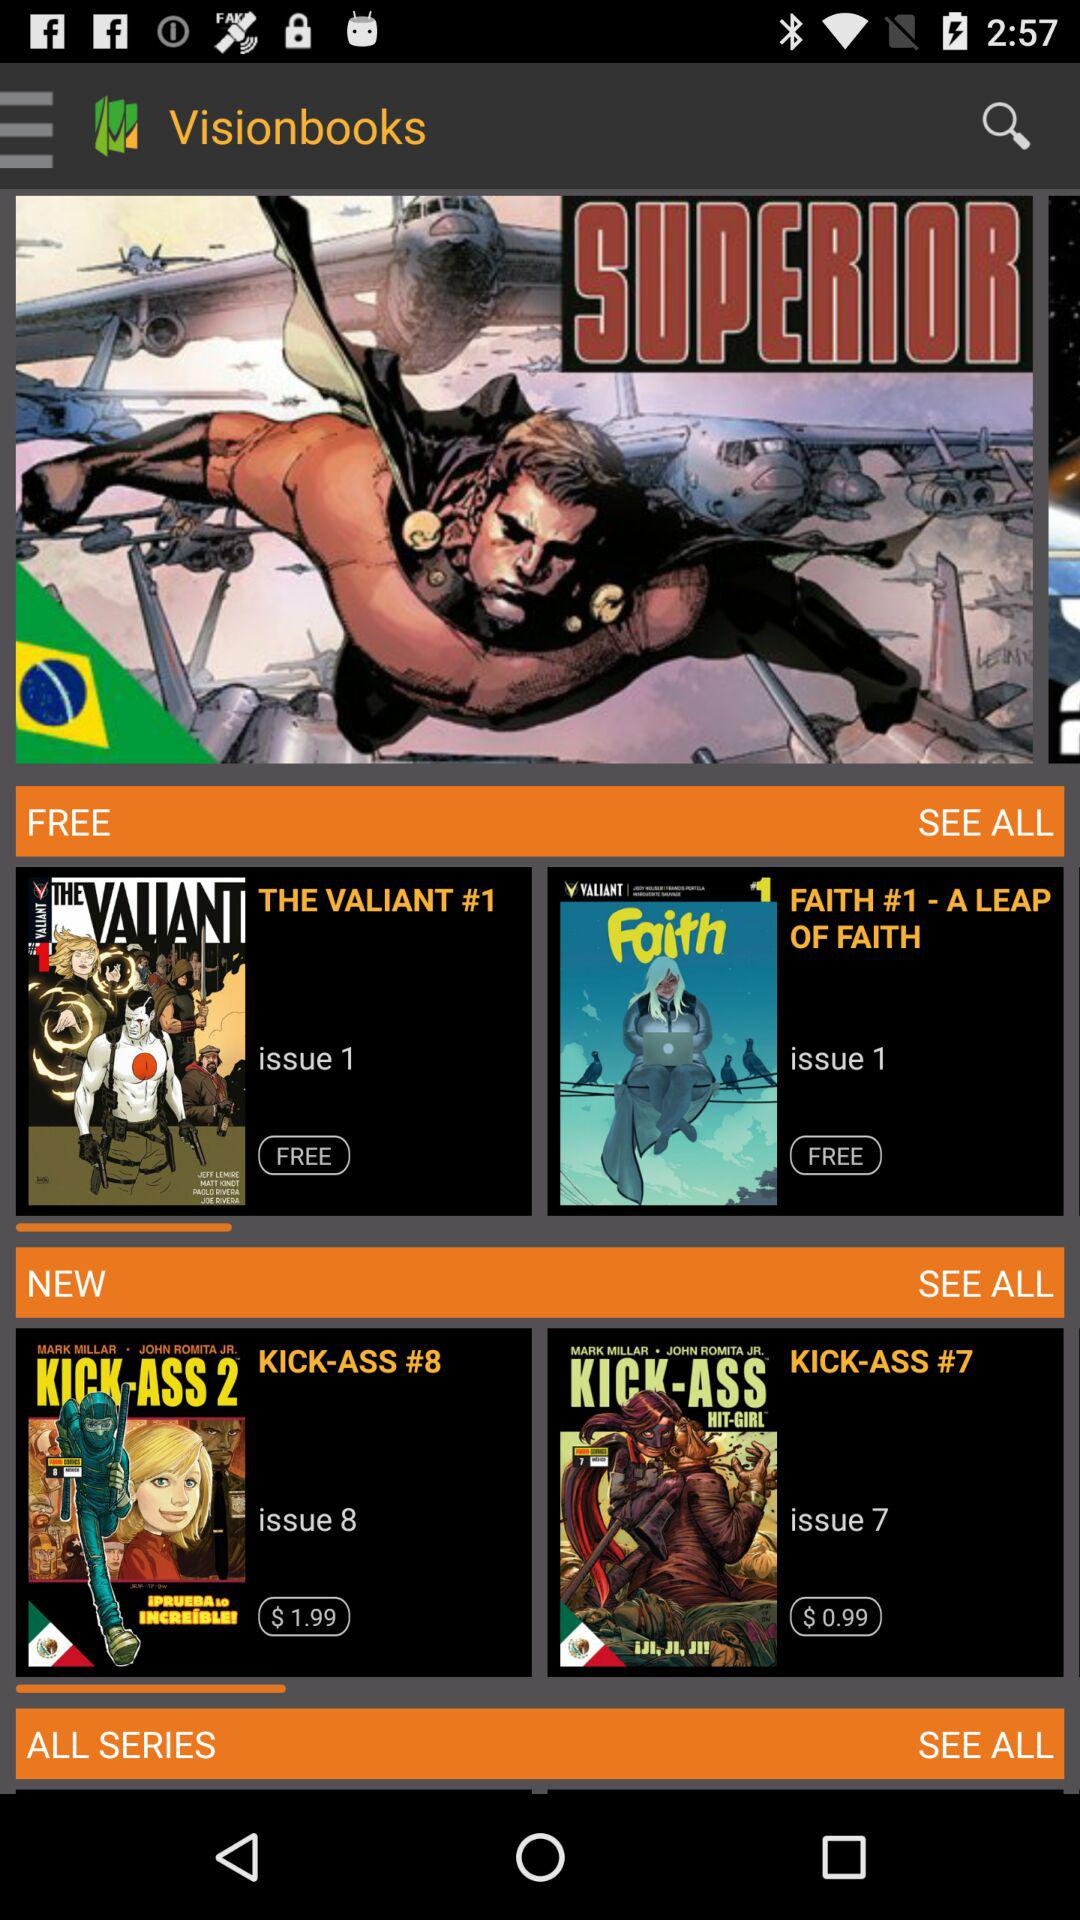How many comic books are in the 'Free' section?
Answer the question using a single word or phrase. 2 